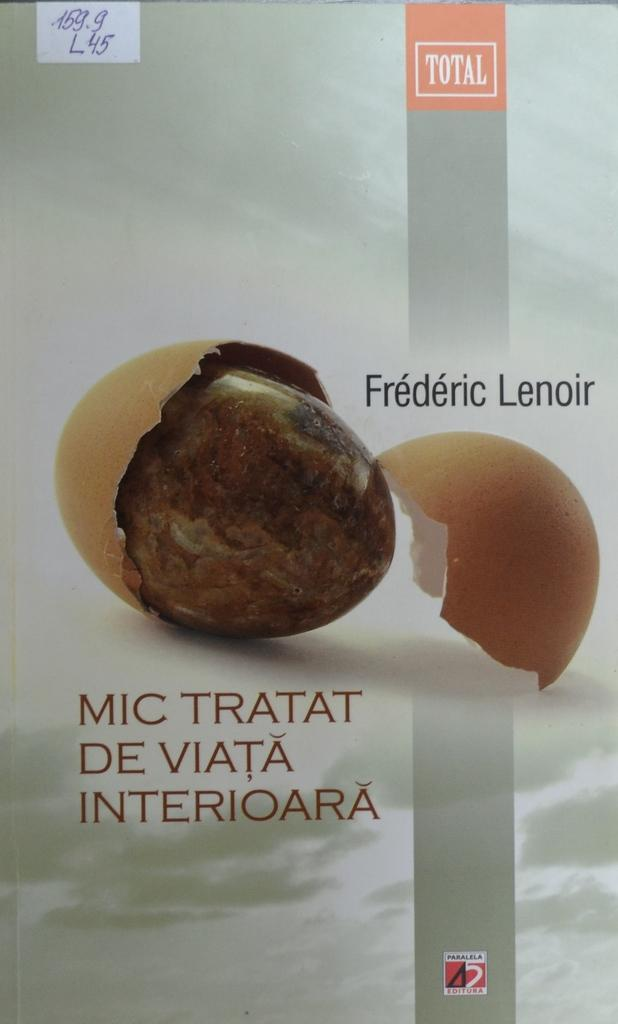What is the condition of the egg in the image? The egg in the image is broken. What else can be seen in the image besides the broken egg? There is text visible in the image. What type of muscle can be seen in the image? There is no muscle visible in the image; it only features a broken egg and text. 